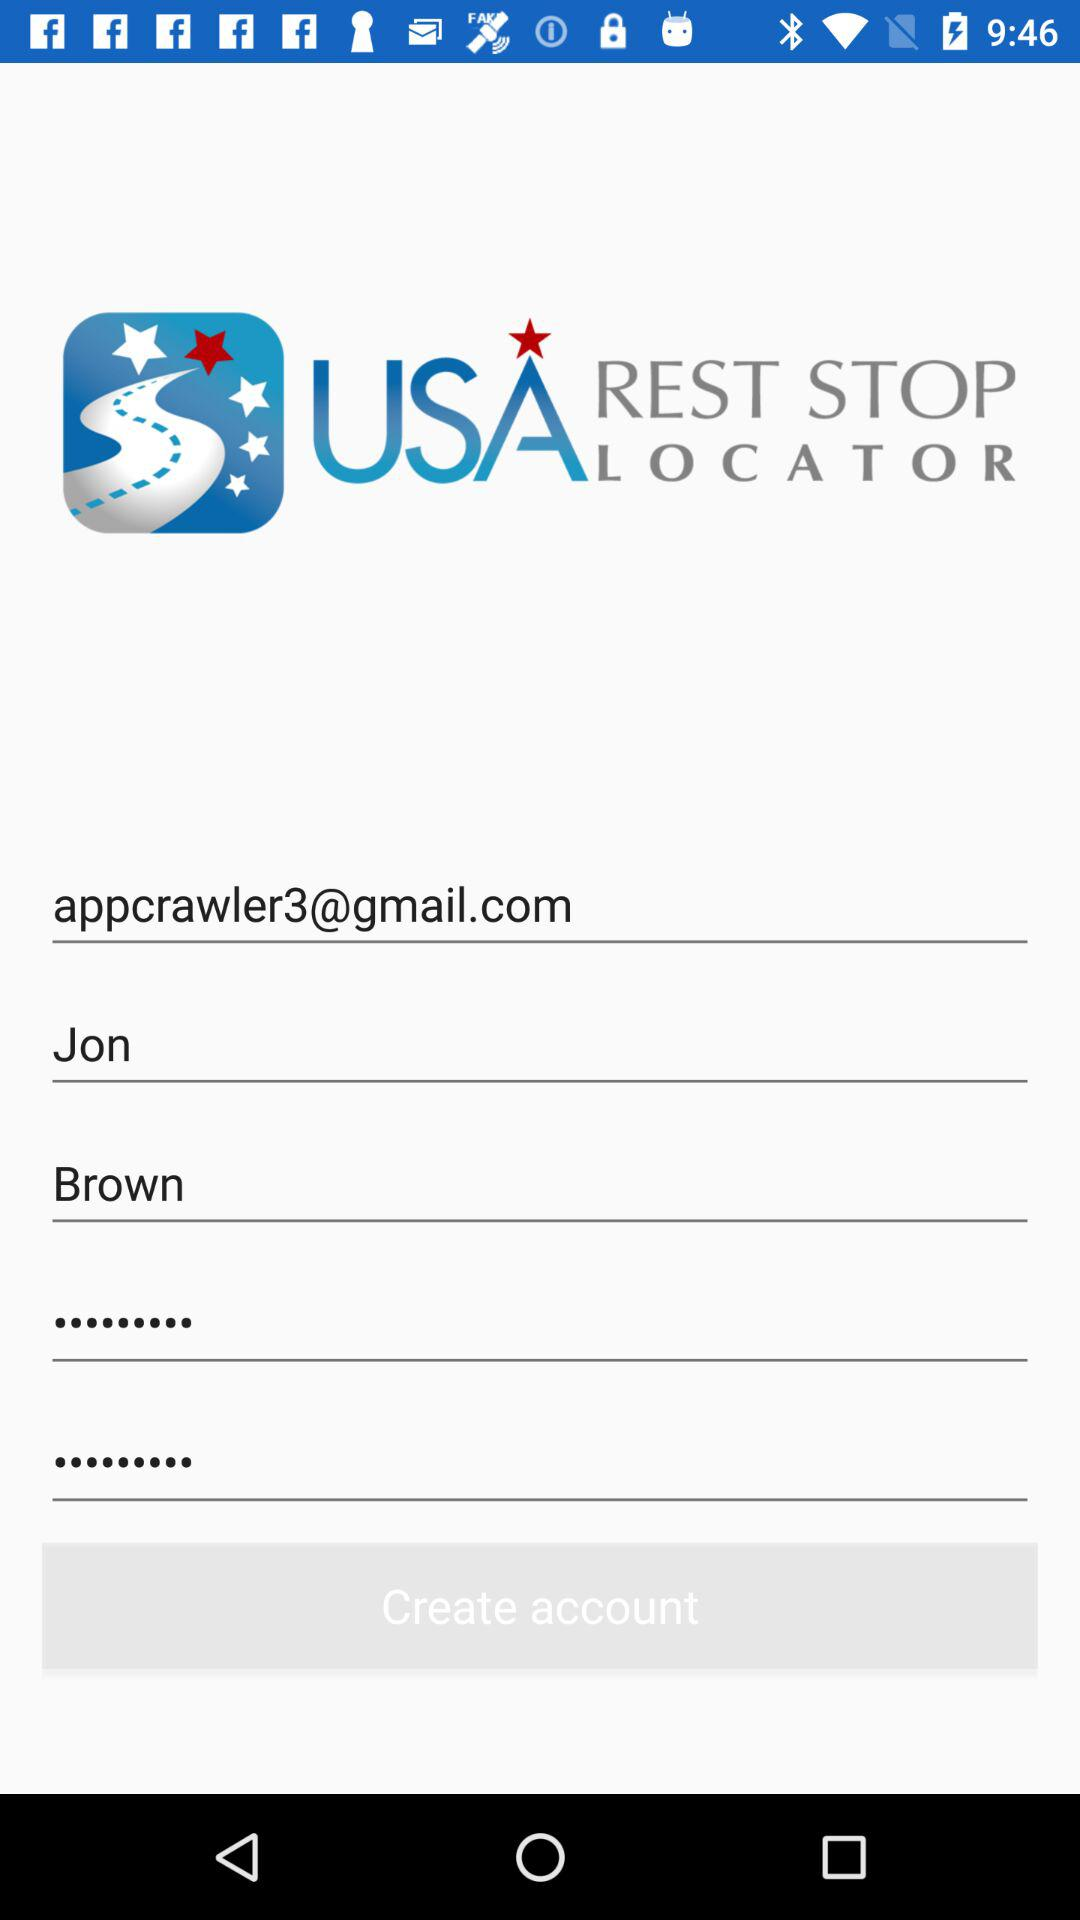What is the name? The name is Jon Brown. 